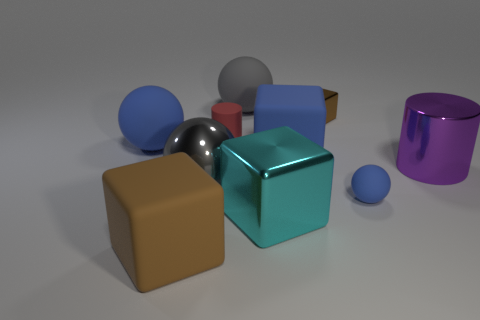Subtract all gray balls. How many brown blocks are left? 2 Subtract all cyan blocks. How many blocks are left? 3 Subtract all large cyan blocks. How many blocks are left? 3 Subtract all purple blocks. Subtract all blue balls. How many blocks are left? 4 Subtract all spheres. How many objects are left? 6 Add 2 purple matte cylinders. How many purple matte cylinders exist? 2 Subtract 0 yellow balls. How many objects are left? 10 Subtract all large blue blocks. Subtract all big blue rubber balls. How many objects are left? 8 Add 2 brown rubber blocks. How many brown rubber blocks are left? 3 